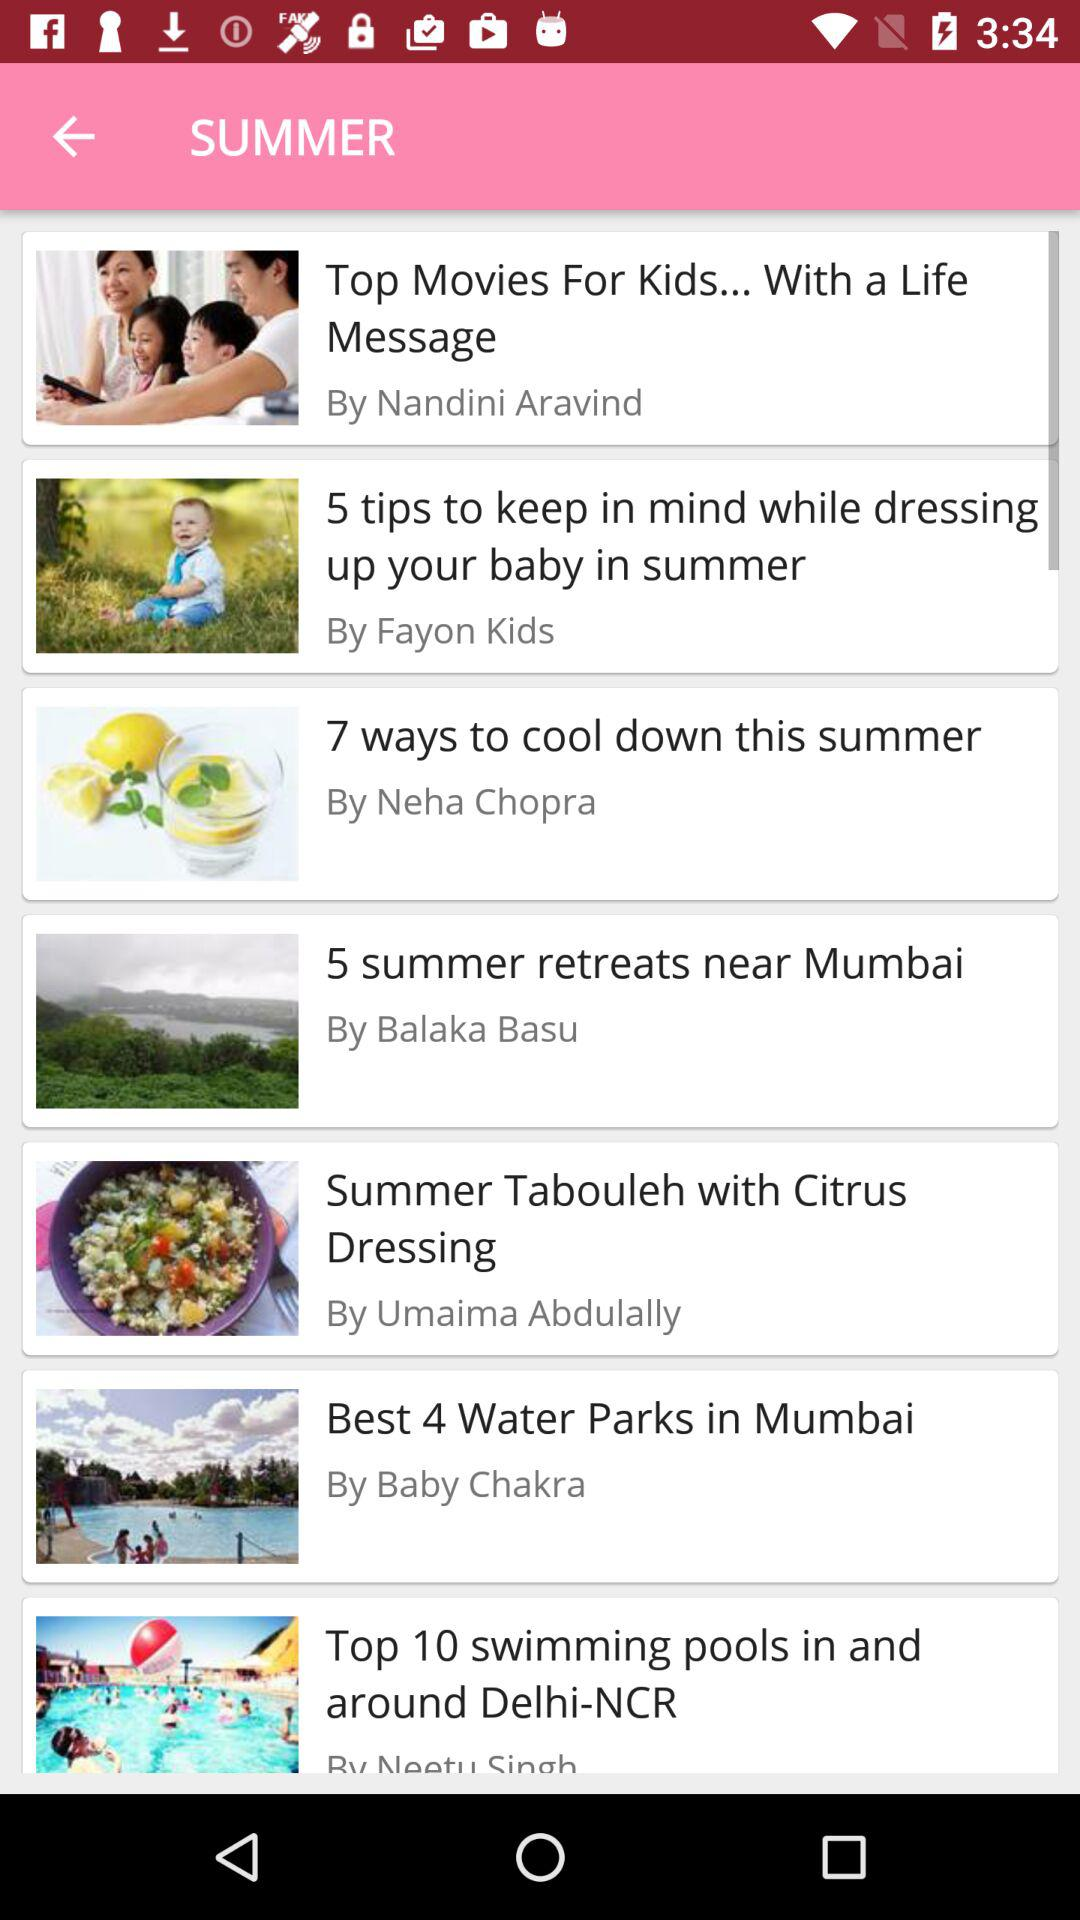By whom is "Summer Tabouleh with Citrus Dressing" proposed? "Summer Tabouleh with Citrus Dressing" is proposed by Umaima Abdulally. 